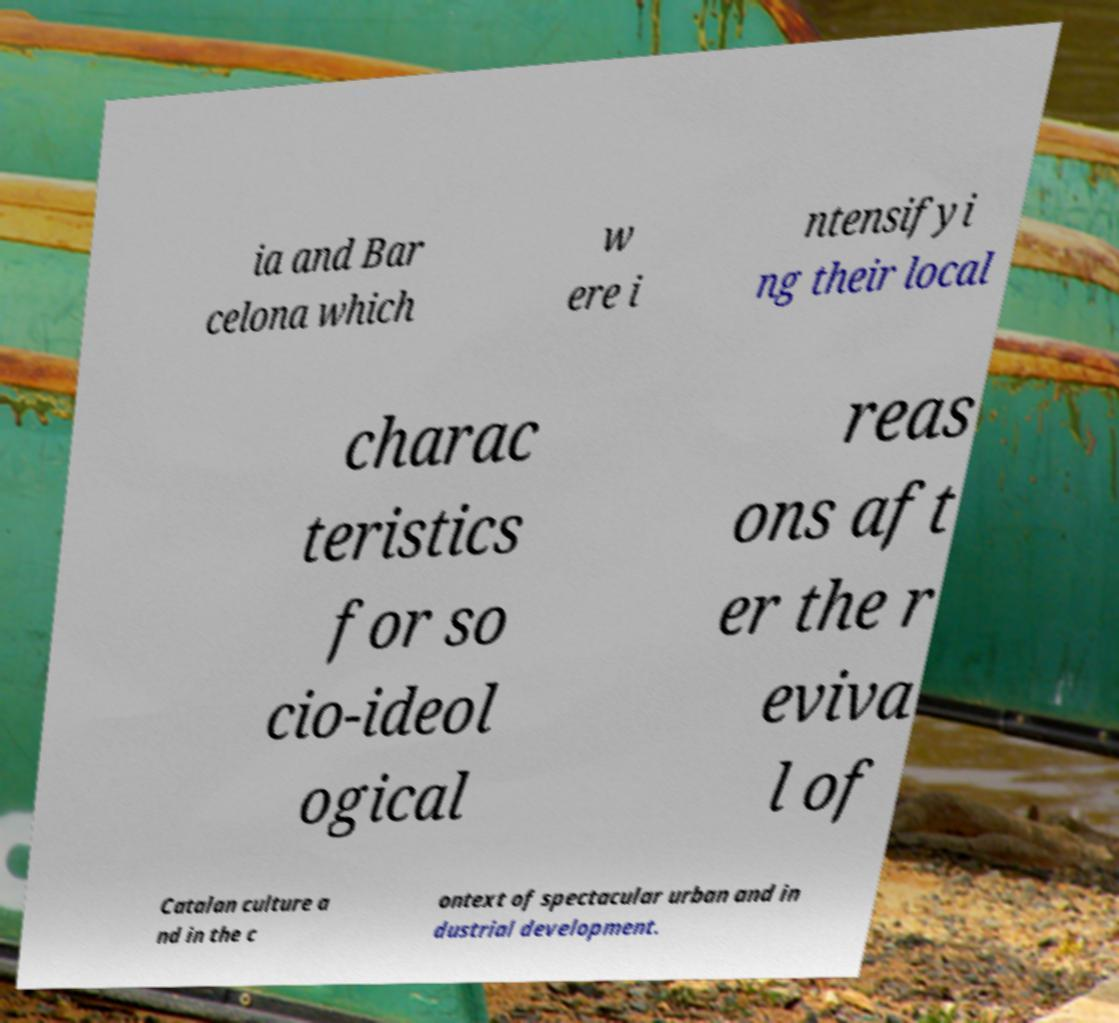Can you accurately transcribe the text from the provided image for me? ia and Bar celona which w ere i ntensifyi ng their local charac teristics for so cio-ideol ogical reas ons aft er the r eviva l of Catalan culture a nd in the c ontext of spectacular urban and in dustrial development. 